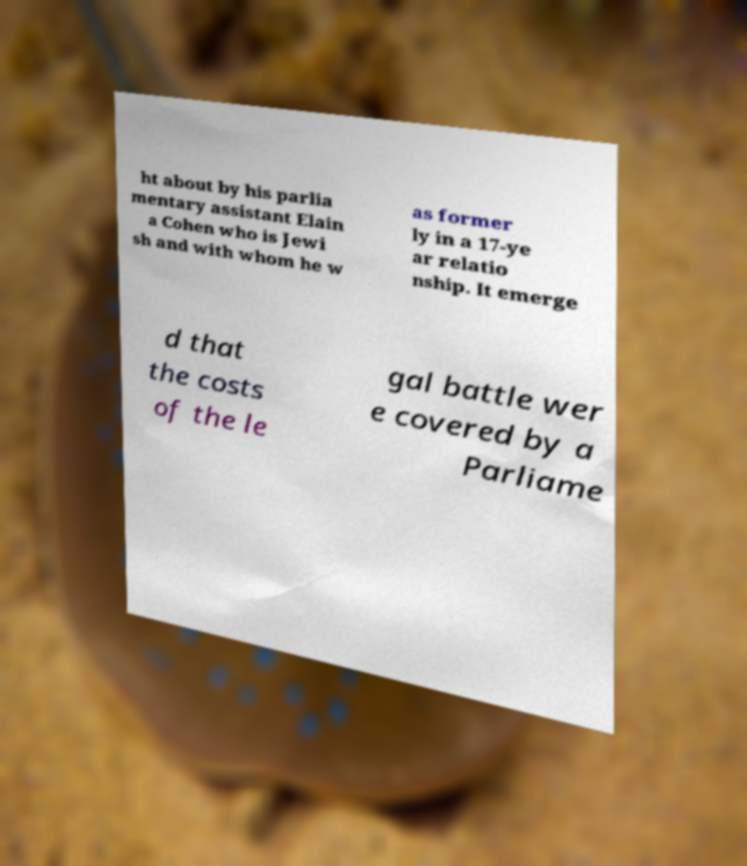Please identify and transcribe the text found in this image. ht about by his parlia mentary assistant Elain a Cohen who is Jewi sh and with whom he w as former ly in a 17-ye ar relatio nship. It emerge d that the costs of the le gal battle wer e covered by a Parliame 